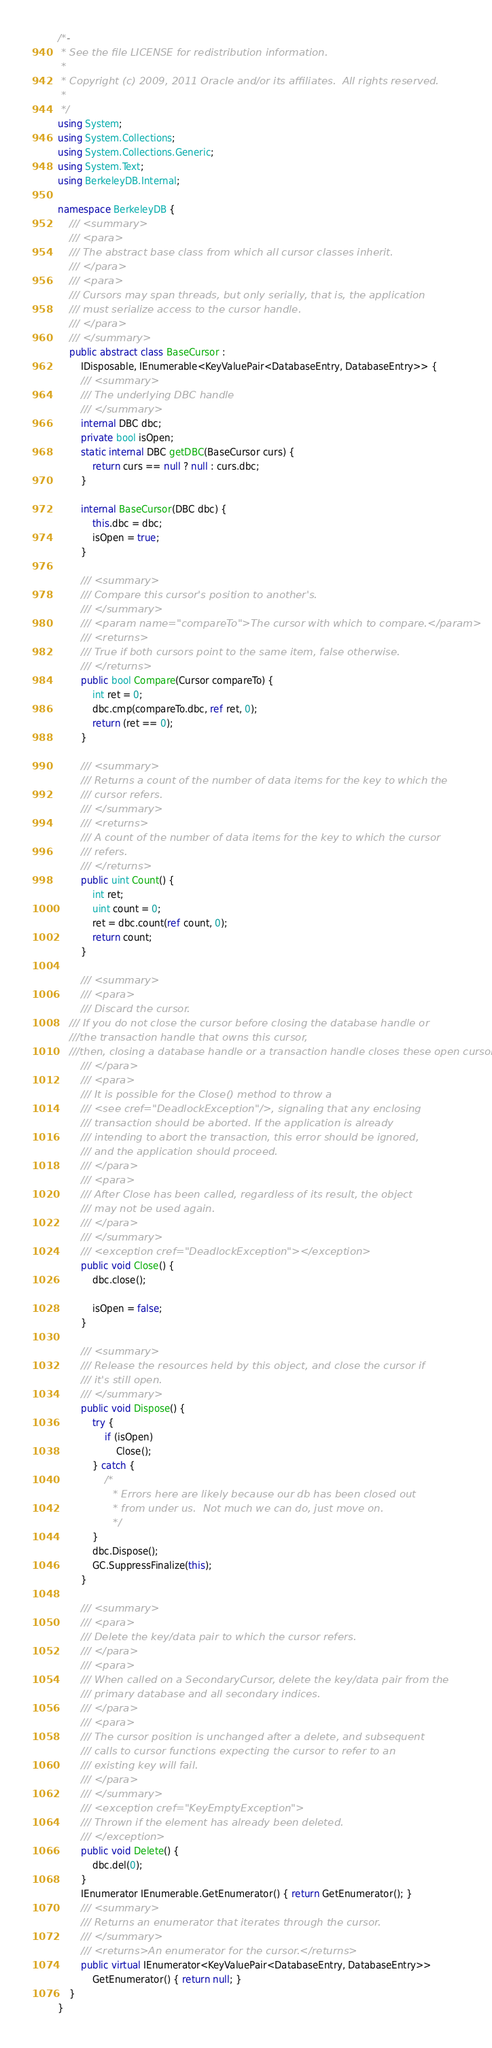<code> <loc_0><loc_0><loc_500><loc_500><_C#_>/*-
 * See the file LICENSE for redistribution information.
 *
 * Copyright (c) 2009, 2011 Oracle and/or its affiliates.  All rights reserved.
 *
 */
using System;
using System.Collections;
using System.Collections.Generic;
using System.Text;
using BerkeleyDB.Internal;

namespace BerkeleyDB {
    /// <summary>
    /// <para>
    /// The abstract base class from which all cursor classes inherit.
    /// </para>
    /// <para>
    /// Cursors may span threads, but only serially, that is, the application
    /// must serialize access to the cursor handle.
    /// </para>
    /// </summary>
    public abstract class BaseCursor :
        IDisposable, IEnumerable<KeyValuePair<DatabaseEntry, DatabaseEntry>> {
        /// <summary>
        /// The underlying DBC handle
        /// </summary>
        internal DBC dbc;
        private bool isOpen;
        static internal DBC getDBC(BaseCursor curs) {
            return curs == null ? null : curs.dbc;
        }

        internal BaseCursor(DBC dbc) {
            this.dbc = dbc;
            isOpen = true;
        }

        /// <summary>
        /// Compare this cursor's position to another's.
        /// </summary>
        /// <param name="compareTo">The cursor with which to compare.</param>
        /// <returns>
        /// True if both cursors point to the same item, false otherwise.
        /// </returns>
        public bool Compare(Cursor compareTo) {
            int ret = 0;
            dbc.cmp(compareTo.dbc, ref ret, 0);
            return (ret == 0);
        }

        /// <summary>
        /// Returns a count of the number of data items for the key to which the
        /// cursor refers. 
        /// </summary>
        /// <returns>
        /// A count of the number of data items for the key to which the cursor
        /// refers.
        /// </returns>
        public uint Count() {
            int ret;
            uint count = 0;
            ret = dbc.count(ref count, 0);
            return count;
        }

        /// <summary>
        /// <para>
        /// Discard the cursor.
	/// If you do not close the cursor before closing the database handle or 
	///the transaction handle that owns this cursor,
	///then, closing a database handle or a transaction handle closes these open cursors.
        /// </para>
        /// <para>
        /// It is possible for the Close() method to throw a
        /// <see cref="DeadlockException"/>, signaling that any enclosing
        /// transaction should be aborted. If the application is already
        /// intending to abort the transaction, this error should be ignored,
        /// and the application should proceed.
        /// </para>
        /// <para>
        /// After Close has been called, regardless of its result, the object
        /// may not be used again. 
        /// </para>
        /// </summary>
        /// <exception cref="DeadlockException"></exception>
        public void Close() {
            dbc.close();

            isOpen = false;
        }

        /// <summary>
        /// Release the resources held by this object, and close the cursor if
        /// it's still open.
        /// </summary>
        public void Dispose() {
            try {
                if (isOpen)
                    Close();
            } catch {
                /* 
                 * Errors here are likely because our db has been closed out
                 * from under us.  Not much we can do, just move on. 
                 */
            }
            dbc.Dispose();
            GC.SuppressFinalize(this);
        }

        /// <summary>
        /// <para>
        /// Delete the key/data pair to which the cursor refers.
        /// </para>
        /// <para>
        /// When called on a SecondaryCursor, delete the key/data pair from the
        /// primary database and all secondary indices.
        /// </para>
        /// <para>
        /// The cursor position is unchanged after a delete, and subsequent
        /// calls to cursor functions expecting the cursor to refer to an
        /// existing key will fail.
        /// </para>
        /// </summary>
        /// <exception cref="KeyEmptyException">
        /// Thrown if the element has already been deleted.
        /// </exception>
        public void Delete() {
            dbc.del(0);
        }
        IEnumerator IEnumerable.GetEnumerator() { return GetEnumerator(); }
        /// <summary>
        /// Returns an enumerator that iterates through the cursor.
        /// </summary>
        /// <returns>An enumerator for the cursor.</returns>
        public virtual IEnumerator<KeyValuePair<DatabaseEntry, DatabaseEntry>>
            GetEnumerator() { return null; }
    }
}
</code> 